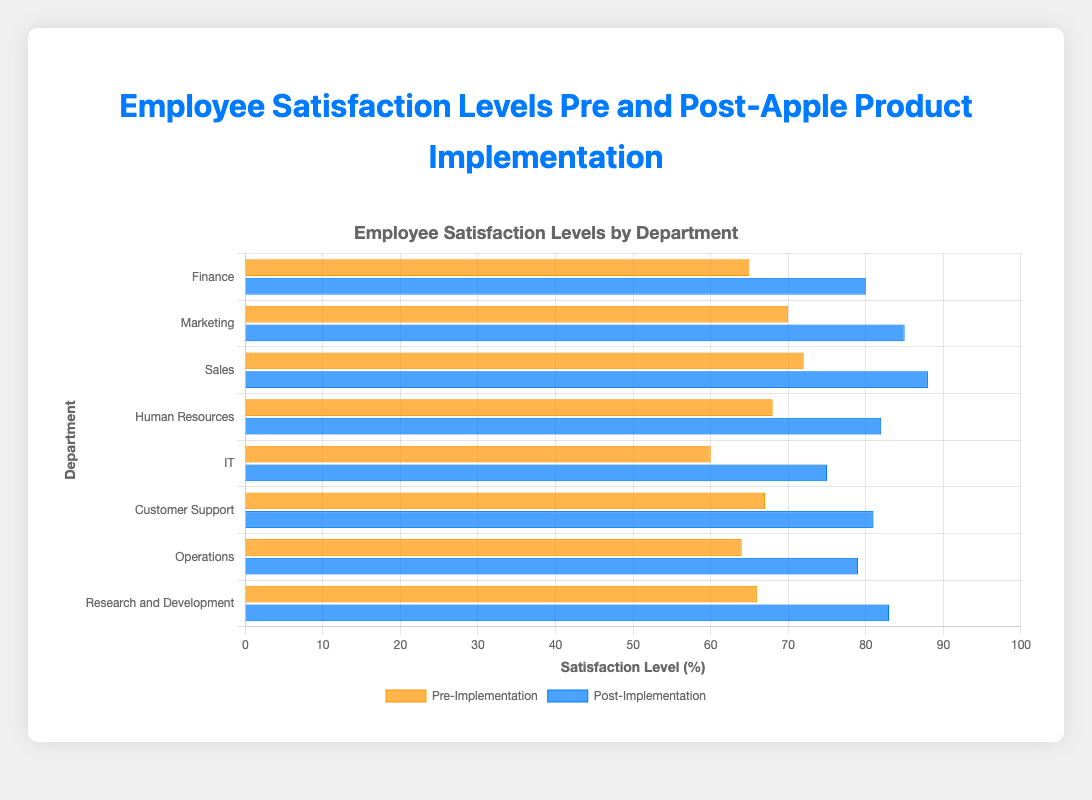Which department showed the highest increase in satisfaction levels after implementing Apple products? To identify the highest increase, subtract the pre-implementation satisfaction from the post-implementation satisfaction for each department. The changes are: Finance (80-65 = 15), Marketing (85-70 = 15), Sales (88-72 = 16), Human Resources (82-68 = 14), IT (75-60 = 15), Customer Support (81-67 = 14), Operations (79-64 = 15), R&D (83-66 = 17). The highest increase is in Research and Development (17).
Answer: Research and Development Which department had the lowest pre-implementation satisfaction level and what was it? Look for the lowest average pre-implementation satisfaction level among the departments. The averages are: Finance (65), Marketing (70), Sales (72), Human Resources (68), IT (60), Customer Support (67), Operations (64), R&D (66). The lowest pre-implementation satisfaction is IT (60).
Answer: IT, 60 What is the combined post-implementation satisfaction level for Marketing and Sales? Add the post-implementation satisfaction levels for Marketing (85) and Sales (88). Therefore, 85 + 88 = 173.
Answer: 173 How much did the satisfaction level increase for the IT department? Subtract the pre-implementation satisfaction level from the post-implementation satisfaction level for the IT department. Therefore, 75 - 60 = 15.
Answer: 15 Which two departments had the same increase in satisfaction levels? Calculate the increase in satisfaction levels for all departments and identify the ones with equal values. Finance, Marketing, IT, and Operations all have an increase of 15. Since we are asked for two, we can choose any pair such as Finance and Marketing.
Answer: Finance and Marketing What is the standard deviation of the pre-implementation satisfaction level for Sales? The standard deviation is already provided in the data. The pre-implementation standard deviation for Sales is 11.
Answer: 11 Among the departments, which has the most evenly distributed (lowest standard deviation) post-implementation satisfaction levels? Look at the standard deviations for post-implementation satisfaction across all departments and identify the lowest. The standard deviations are: Finance (8), Marketing (9), Sales (7), Human Resources (10), IT (11), Customer Support (10), Operations (8), R&D (9). The lowest standard deviation is for Sales (7).
Answer: Sales What is the average of all post-implementation satisfaction levels? Sum all post-implementation satisfaction levels and divide by the number of departments. (80 + 85 + 88 + 82 + 75 + 81 + 79 + 83) / 8 = 653 / 8 = 81.625
Answer: 81.625 Which department had the smallest gap between its pre- and post-implementation satisfaction levels? Determine the difference (gap) between pre- and post-implementation satisfaction levels for each department. The smallest gap is Human Resources (82 - 68 = 14) and Customer Support (81 - 67 = 14). Hence, we can choose either.
Answer: Human Resources or Customer Support 